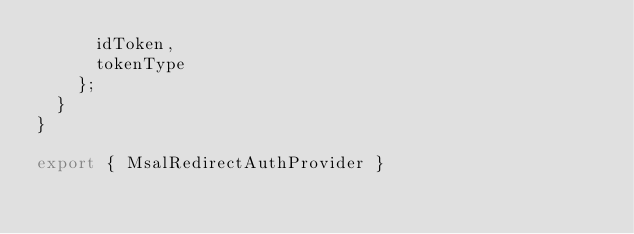Convert code to text. <code><loc_0><loc_0><loc_500><loc_500><_JavaScript_>      idToken,
      tokenType
    };
  }
}

export { MsalRedirectAuthProvider }</code> 